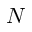Convert formula to latex. <formula><loc_0><loc_0><loc_500><loc_500>N</formula> 